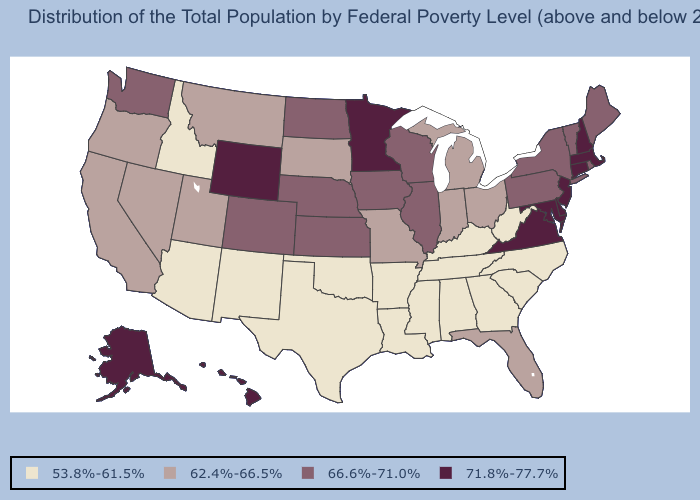Name the states that have a value in the range 66.6%-71.0%?
Concise answer only. Colorado, Illinois, Iowa, Kansas, Maine, Nebraska, New York, North Dakota, Pennsylvania, Rhode Island, Vermont, Washington, Wisconsin. Which states have the lowest value in the USA?
Answer briefly. Alabama, Arizona, Arkansas, Georgia, Idaho, Kentucky, Louisiana, Mississippi, New Mexico, North Carolina, Oklahoma, South Carolina, Tennessee, Texas, West Virginia. Does South Carolina have the lowest value in the USA?
Give a very brief answer. Yes. What is the value of South Carolina?
Quick response, please. 53.8%-61.5%. Does South Dakota have a lower value than Hawaii?
Short answer required. Yes. Which states hav the highest value in the MidWest?
Answer briefly. Minnesota. Name the states that have a value in the range 66.6%-71.0%?
Answer briefly. Colorado, Illinois, Iowa, Kansas, Maine, Nebraska, New York, North Dakota, Pennsylvania, Rhode Island, Vermont, Washington, Wisconsin. Does Florida have the lowest value in the South?
Answer briefly. No. Name the states that have a value in the range 71.8%-77.7%?
Be succinct. Alaska, Connecticut, Delaware, Hawaii, Maryland, Massachusetts, Minnesota, New Hampshire, New Jersey, Virginia, Wyoming. Does Illinois have the lowest value in the MidWest?
Answer briefly. No. What is the value of Oklahoma?
Answer briefly. 53.8%-61.5%. Does New Mexico have the highest value in the USA?
Keep it brief. No. What is the value of Tennessee?
Keep it brief. 53.8%-61.5%. Is the legend a continuous bar?
Quick response, please. No. 